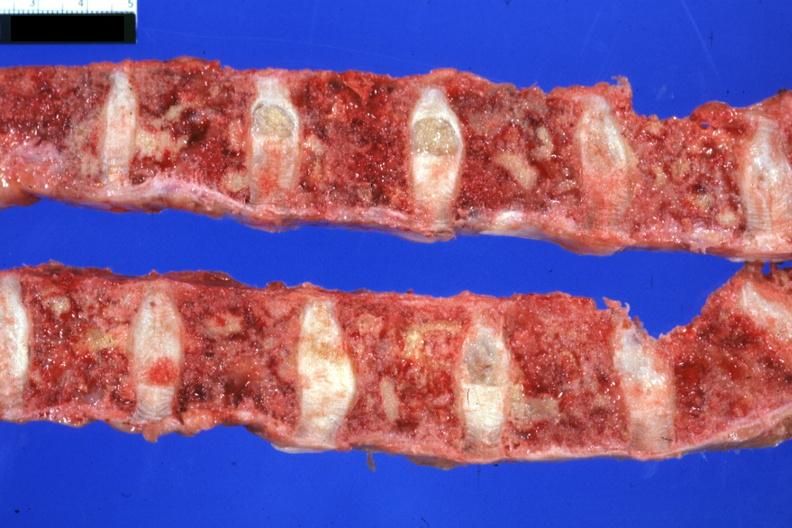how is excellent multiple lesions sigmoid colon adenocarcinoma 6mo post colon resection with multiple complications?
Answer the question using a single word or phrase. Papillary 